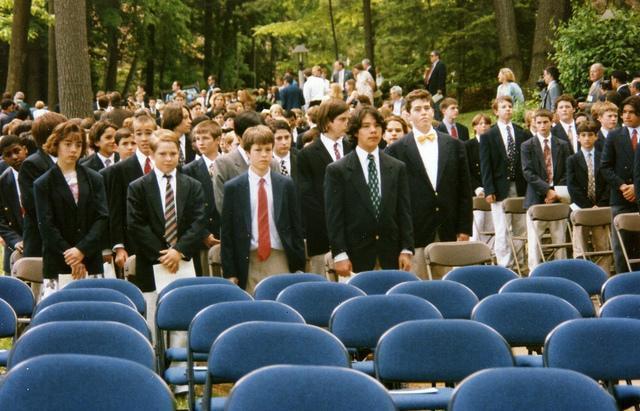How many people can be seen?
Give a very brief answer. 9. How many chairs are there?
Give a very brief answer. 10. 